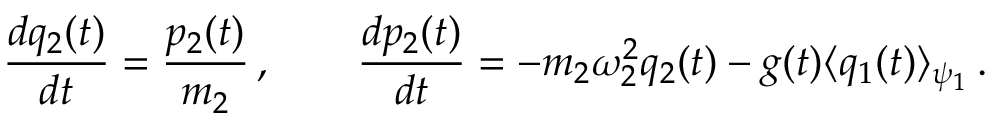<formula> <loc_0><loc_0><loc_500><loc_500>\frac { d q _ { 2 } ( t ) } { d t } = \frac { p _ { 2 } ( t ) } { m _ { 2 } } \, , \quad \frac { d p _ { 2 } ( t ) } { d t } = - m _ { 2 } \omega _ { 2 } ^ { 2 } q _ { 2 } ( t ) - g ( t ) \langle q _ { 1 } ( t ) \rangle _ { \psi _ { 1 } } \, .</formula> 